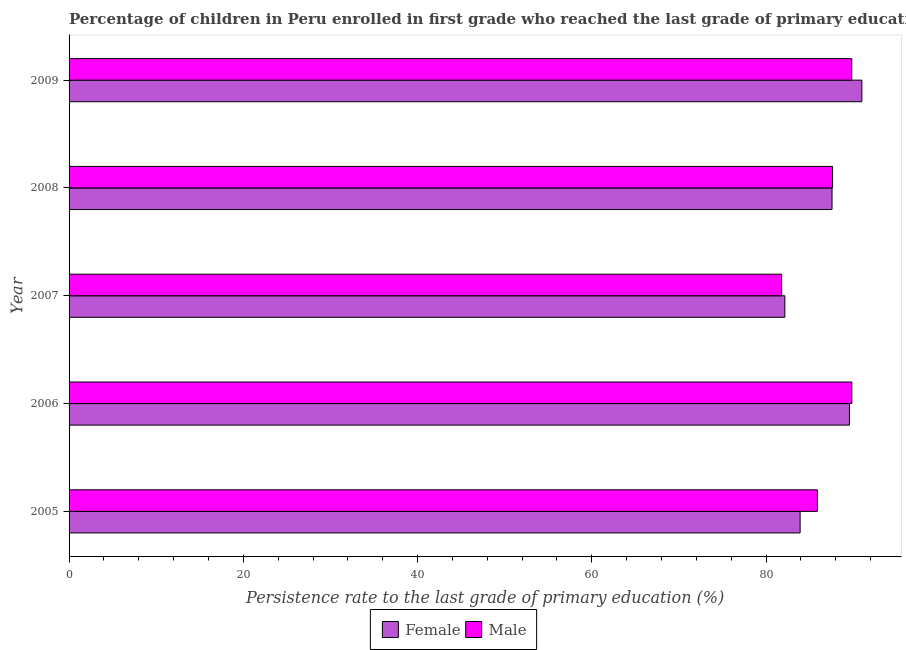How many groups of bars are there?
Your response must be concise. 5. Are the number of bars per tick equal to the number of legend labels?
Your answer should be very brief. Yes. Are the number of bars on each tick of the Y-axis equal?
Offer a terse response. Yes. What is the persistence rate of male students in 2008?
Offer a very short reply. 87.63. Across all years, what is the maximum persistence rate of male students?
Make the answer very short. 89.84. Across all years, what is the minimum persistence rate of male students?
Give a very brief answer. 81.79. What is the total persistence rate of female students in the graph?
Offer a terse response. 434.19. What is the difference between the persistence rate of male students in 2006 and that in 2008?
Your answer should be very brief. 2.21. What is the difference between the persistence rate of male students in 2005 and the persistence rate of female students in 2006?
Provide a short and direct response. -3.68. What is the average persistence rate of female students per year?
Offer a terse response. 86.84. In the year 2009, what is the difference between the persistence rate of male students and persistence rate of female students?
Ensure brevity in your answer.  -1.16. What is the ratio of the persistence rate of male students in 2006 to that in 2008?
Give a very brief answer. 1.02. Is the difference between the persistence rate of female students in 2007 and 2008 greater than the difference between the persistence rate of male students in 2007 and 2008?
Provide a succinct answer. Yes. What is the difference between the highest and the second highest persistence rate of male students?
Provide a succinct answer. 0.01. What is the difference between the highest and the lowest persistence rate of female students?
Your answer should be compact. 8.84. What does the 2nd bar from the top in 2008 represents?
Give a very brief answer. Female. What does the 1st bar from the bottom in 2008 represents?
Your answer should be compact. Female. How many bars are there?
Keep it short and to the point. 10. Are all the bars in the graph horizontal?
Your answer should be very brief. Yes. Does the graph contain any zero values?
Your answer should be very brief. No. Does the graph contain grids?
Your answer should be very brief. No. Where does the legend appear in the graph?
Provide a succinct answer. Bottom center. How many legend labels are there?
Give a very brief answer. 2. What is the title of the graph?
Keep it short and to the point. Percentage of children in Peru enrolled in first grade who reached the last grade of primary education. What is the label or title of the X-axis?
Your answer should be compact. Persistence rate to the last grade of primary education (%). What is the label or title of the Y-axis?
Give a very brief answer. Year. What is the Persistence rate to the last grade of primary education (%) of Female in 2005?
Your answer should be compact. 83.91. What is the Persistence rate to the last grade of primary education (%) in Male in 2005?
Ensure brevity in your answer.  85.89. What is the Persistence rate to the last grade of primary education (%) in Female in 2006?
Give a very brief answer. 89.57. What is the Persistence rate to the last grade of primary education (%) of Male in 2006?
Give a very brief answer. 89.84. What is the Persistence rate to the last grade of primary education (%) in Female in 2007?
Ensure brevity in your answer.  82.15. What is the Persistence rate to the last grade of primary education (%) in Male in 2007?
Give a very brief answer. 81.79. What is the Persistence rate to the last grade of primary education (%) of Female in 2008?
Provide a short and direct response. 87.57. What is the Persistence rate to the last grade of primary education (%) in Male in 2008?
Your response must be concise. 87.63. What is the Persistence rate to the last grade of primary education (%) in Female in 2009?
Offer a very short reply. 90.99. What is the Persistence rate to the last grade of primary education (%) in Male in 2009?
Offer a terse response. 89.84. Across all years, what is the maximum Persistence rate to the last grade of primary education (%) of Female?
Your answer should be very brief. 90.99. Across all years, what is the maximum Persistence rate to the last grade of primary education (%) in Male?
Your answer should be very brief. 89.84. Across all years, what is the minimum Persistence rate to the last grade of primary education (%) of Female?
Offer a terse response. 82.15. Across all years, what is the minimum Persistence rate to the last grade of primary education (%) of Male?
Your answer should be very brief. 81.79. What is the total Persistence rate to the last grade of primary education (%) of Female in the graph?
Your answer should be compact. 434.19. What is the total Persistence rate to the last grade of primary education (%) in Male in the graph?
Make the answer very short. 434.98. What is the difference between the Persistence rate to the last grade of primary education (%) of Female in 2005 and that in 2006?
Offer a terse response. -5.66. What is the difference between the Persistence rate to the last grade of primary education (%) in Male in 2005 and that in 2006?
Give a very brief answer. -3.96. What is the difference between the Persistence rate to the last grade of primary education (%) in Female in 2005 and that in 2007?
Make the answer very short. 1.76. What is the difference between the Persistence rate to the last grade of primary education (%) of Male in 2005 and that in 2007?
Your answer should be compact. 4.1. What is the difference between the Persistence rate to the last grade of primary education (%) in Female in 2005 and that in 2008?
Keep it short and to the point. -3.66. What is the difference between the Persistence rate to the last grade of primary education (%) in Male in 2005 and that in 2008?
Provide a short and direct response. -1.74. What is the difference between the Persistence rate to the last grade of primary education (%) of Female in 2005 and that in 2009?
Offer a very short reply. -7.09. What is the difference between the Persistence rate to the last grade of primary education (%) in Male in 2005 and that in 2009?
Provide a succinct answer. -3.95. What is the difference between the Persistence rate to the last grade of primary education (%) in Female in 2006 and that in 2007?
Provide a succinct answer. 7.42. What is the difference between the Persistence rate to the last grade of primary education (%) of Male in 2006 and that in 2007?
Make the answer very short. 8.06. What is the difference between the Persistence rate to the last grade of primary education (%) of Female in 2006 and that in 2008?
Keep it short and to the point. 2. What is the difference between the Persistence rate to the last grade of primary education (%) in Male in 2006 and that in 2008?
Provide a short and direct response. 2.21. What is the difference between the Persistence rate to the last grade of primary education (%) in Female in 2006 and that in 2009?
Your response must be concise. -1.42. What is the difference between the Persistence rate to the last grade of primary education (%) of Male in 2006 and that in 2009?
Provide a succinct answer. 0.01. What is the difference between the Persistence rate to the last grade of primary education (%) of Female in 2007 and that in 2008?
Keep it short and to the point. -5.42. What is the difference between the Persistence rate to the last grade of primary education (%) of Male in 2007 and that in 2008?
Provide a succinct answer. -5.85. What is the difference between the Persistence rate to the last grade of primary education (%) in Female in 2007 and that in 2009?
Keep it short and to the point. -8.84. What is the difference between the Persistence rate to the last grade of primary education (%) in Male in 2007 and that in 2009?
Your answer should be compact. -8.05. What is the difference between the Persistence rate to the last grade of primary education (%) of Female in 2008 and that in 2009?
Keep it short and to the point. -3.42. What is the difference between the Persistence rate to the last grade of primary education (%) in Male in 2008 and that in 2009?
Give a very brief answer. -2.2. What is the difference between the Persistence rate to the last grade of primary education (%) of Female in 2005 and the Persistence rate to the last grade of primary education (%) of Male in 2006?
Your answer should be compact. -5.94. What is the difference between the Persistence rate to the last grade of primary education (%) of Female in 2005 and the Persistence rate to the last grade of primary education (%) of Male in 2007?
Your answer should be very brief. 2.12. What is the difference between the Persistence rate to the last grade of primary education (%) in Female in 2005 and the Persistence rate to the last grade of primary education (%) in Male in 2008?
Ensure brevity in your answer.  -3.72. What is the difference between the Persistence rate to the last grade of primary education (%) of Female in 2005 and the Persistence rate to the last grade of primary education (%) of Male in 2009?
Your answer should be very brief. -5.93. What is the difference between the Persistence rate to the last grade of primary education (%) in Female in 2006 and the Persistence rate to the last grade of primary education (%) in Male in 2007?
Give a very brief answer. 7.78. What is the difference between the Persistence rate to the last grade of primary education (%) of Female in 2006 and the Persistence rate to the last grade of primary education (%) of Male in 2008?
Offer a very short reply. 1.94. What is the difference between the Persistence rate to the last grade of primary education (%) in Female in 2006 and the Persistence rate to the last grade of primary education (%) in Male in 2009?
Your response must be concise. -0.27. What is the difference between the Persistence rate to the last grade of primary education (%) of Female in 2007 and the Persistence rate to the last grade of primary education (%) of Male in 2008?
Your answer should be compact. -5.48. What is the difference between the Persistence rate to the last grade of primary education (%) of Female in 2007 and the Persistence rate to the last grade of primary education (%) of Male in 2009?
Offer a very short reply. -7.68. What is the difference between the Persistence rate to the last grade of primary education (%) in Female in 2008 and the Persistence rate to the last grade of primary education (%) in Male in 2009?
Provide a short and direct response. -2.27. What is the average Persistence rate to the last grade of primary education (%) of Female per year?
Provide a succinct answer. 86.84. What is the average Persistence rate to the last grade of primary education (%) in Male per year?
Ensure brevity in your answer.  87. In the year 2005, what is the difference between the Persistence rate to the last grade of primary education (%) in Female and Persistence rate to the last grade of primary education (%) in Male?
Keep it short and to the point. -1.98. In the year 2006, what is the difference between the Persistence rate to the last grade of primary education (%) in Female and Persistence rate to the last grade of primary education (%) in Male?
Your response must be concise. -0.28. In the year 2007, what is the difference between the Persistence rate to the last grade of primary education (%) of Female and Persistence rate to the last grade of primary education (%) of Male?
Provide a short and direct response. 0.37. In the year 2008, what is the difference between the Persistence rate to the last grade of primary education (%) of Female and Persistence rate to the last grade of primary education (%) of Male?
Provide a short and direct response. -0.06. In the year 2009, what is the difference between the Persistence rate to the last grade of primary education (%) in Female and Persistence rate to the last grade of primary education (%) in Male?
Your response must be concise. 1.16. What is the ratio of the Persistence rate to the last grade of primary education (%) in Female in 2005 to that in 2006?
Provide a succinct answer. 0.94. What is the ratio of the Persistence rate to the last grade of primary education (%) in Male in 2005 to that in 2006?
Provide a short and direct response. 0.96. What is the ratio of the Persistence rate to the last grade of primary education (%) of Female in 2005 to that in 2007?
Offer a very short reply. 1.02. What is the ratio of the Persistence rate to the last grade of primary education (%) in Male in 2005 to that in 2007?
Your response must be concise. 1.05. What is the ratio of the Persistence rate to the last grade of primary education (%) in Female in 2005 to that in 2008?
Keep it short and to the point. 0.96. What is the ratio of the Persistence rate to the last grade of primary education (%) in Male in 2005 to that in 2008?
Your answer should be very brief. 0.98. What is the ratio of the Persistence rate to the last grade of primary education (%) in Female in 2005 to that in 2009?
Make the answer very short. 0.92. What is the ratio of the Persistence rate to the last grade of primary education (%) of Male in 2005 to that in 2009?
Your answer should be very brief. 0.96. What is the ratio of the Persistence rate to the last grade of primary education (%) in Female in 2006 to that in 2007?
Keep it short and to the point. 1.09. What is the ratio of the Persistence rate to the last grade of primary education (%) in Male in 2006 to that in 2007?
Provide a succinct answer. 1.1. What is the ratio of the Persistence rate to the last grade of primary education (%) in Female in 2006 to that in 2008?
Your response must be concise. 1.02. What is the ratio of the Persistence rate to the last grade of primary education (%) in Male in 2006 to that in 2008?
Your answer should be compact. 1.03. What is the ratio of the Persistence rate to the last grade of primary education (%) in Female in 2006 to that in 2009?
Ensure brevity in your answer.  0.98. What is the ratio of the Persistence rate to the last grade of primary education (%) of Female in 2007 to that in 2008?
Offer a very short reply. 0.94. What is the ratio of the Persistence rate to the last grade of primary education (%) in Male in 2007 to that in 2008?
Your response must be concise. 0.93. What is the ratio of the Persistence rate to the last grade of primary education (%) in Female in 2007 to that in 2009?
Ensure brevity in your answer.  0.9. What is the ratio of the Persistence rate to the last grade of primary education (%) in Male in 2007 to that in 2009?
Offer a terse response. 0.91. What is the ratio of the Persistence rate to the last grade of primary education (%) in Female in 2008 to that in 2009?
Your answer should be compact. 0.96. What is the ratio of the Persistence rate to the last grade of primary education (%) of Male in 2008 to that in 2009?
Offer a very short reply. 0.98. What is the difference between the highest and the second highest Persistence rate to the last grade of primary education (%) of Female?
Your answer should be very brief. 1.42. What is the difference between the highest and the second highest Persistence rate to the last grade of primary education (%) of Male?
Keep it short and to the point. 0.01. What is the difference between the highest and the lowest Persistence rate to the last grade of primary education (%) of Female?
Make the answer very short. 8.84. What is the difference between the highest and the lowest Persistence rate to the last grade of primary education (%) of Male?
Your answer should be compact. 8.06. 